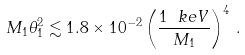Convert formula to latex. <formula><loc_0><loc_0><loc_500><loc_500>M _ { 1 } \theta _ { 1 } ^ { 2 } \lesssim 1 . 8 \times 1 0 ^ { - 2 } \left ( \frac { 1 \ k e V } { M _ { 1 } } \right ) ^ { 4 } \, .</formula> 